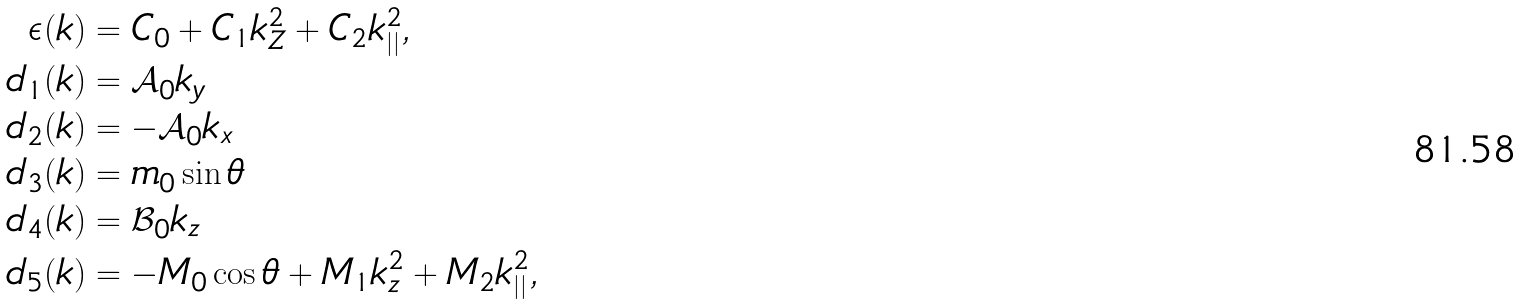<formula> <loc_0><loc_0><loc_500><loc_500>\epsilon ( { k } ) & = C _ { 0 } + C _ { 1 } k _ { Z } ^ { 2 } + C _ { 2 } k _ { | | } ^ { 2 } , \\ d _ { 1 } ( { k } ) & = \mathcal { A } _ { 0 } k _ { y } \\ d _ { 2 } ( { k } ) & = - \mathcal { A } _ { 0 } k _ { x } \\ d _ { 3 } ( { k } ) & = m _ { 0 } \sin \theta \\ d _ { 4 } ( { k } ) & = \mathcal { B } _ { 0 } k _ { z } \\ d _ { 5 } ( { k } ) & = - M _ { 0 } \cos \theta + M _ { 1 } k _ { z } ^ { 2 } + M _ { 2 } k _ { | | } ^ { 2 } ,</formula> 